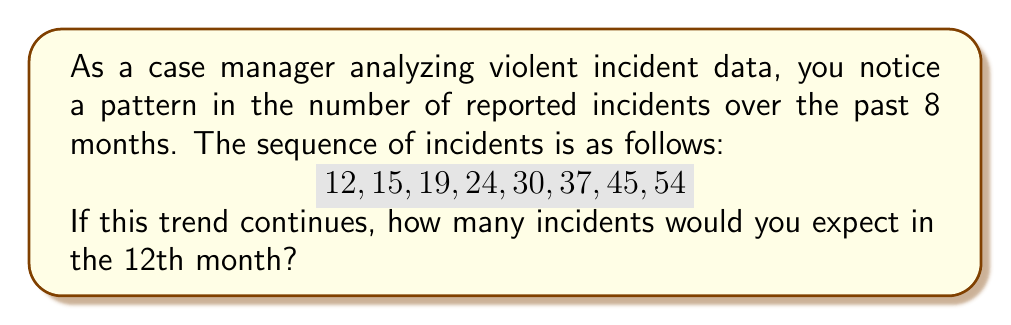Could you help me with this problem? To solve this problem, we need to analyze the given sequence and identify the pattern:

12, 15, 19, 24, 30, 37, 45, 54

Let's calculate the differences between consecutive terms:

15 - 12 = 3
19 - 15 = 4
24 - 19 = 5
30 - 24 = 6
37 - 30 = 7
45 - 37 = 8
54 - 45 = 9

We can observe that the differences form an arithmetic sequence: 3, 4, 5, 6, 7, 8, 9

The pattern suggests that each month, the increase in incidents grows by 1. We can represent this as an arithmetic sequence of second order.

Let $a_n$ be the number of incidents in the $n$-th month. The second-order difference $\Delta^2 a_n$ is constant and equal to 1.

We can use the formula for the $n$-th term of a second-order arithmetic sequence:

$$a_n = \frac{n(n-1)}{2}\Delta^2 a_n + (n-1)\Delta a_1 + a_1$$

Where:
$\Delta^2 a_n = 1$ (constant second-order difference)
$\Delta a_1 = 3$ (first-order difference between the first two terms)
$a_1 = 12$ (first term of the sequence)

Substituting these values and $n = 12$ (for the 12th month):

$$a_{12} = \frac{12(12-1)}{2} \cdot 1 + (12-1) \cdot 3 + 12$$
$$a_{12} = 66 + 33 + 12$$
$$a_{12} = 111$$

Therefore, we would expect 111 incidents in the 12th month if this trend continues.
Answer: 111 incidents 